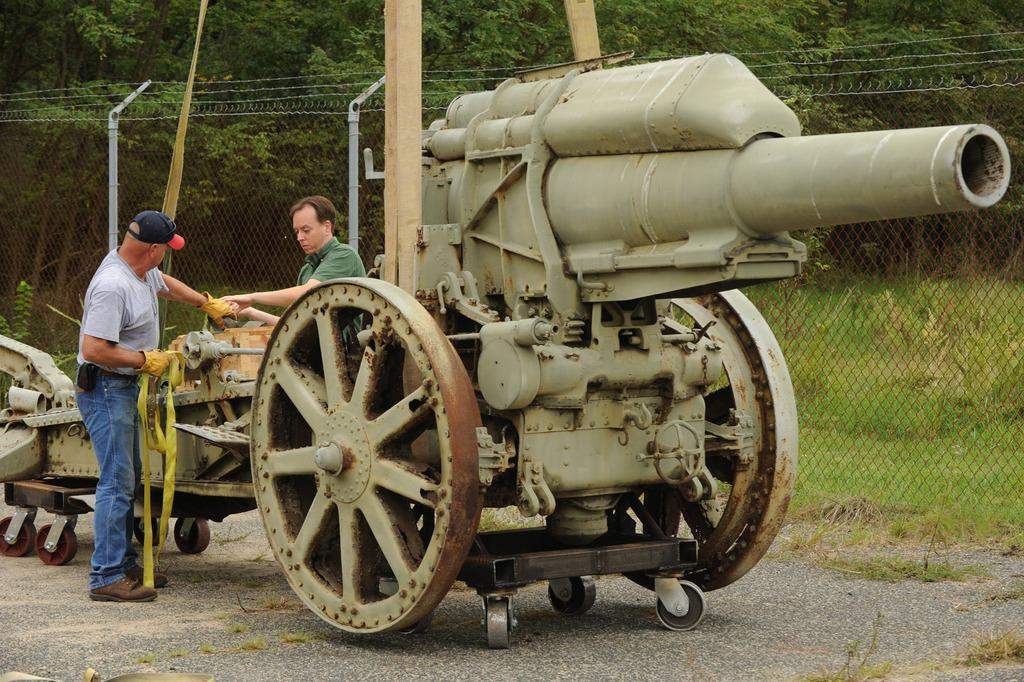What is the main object in the foreground of the image? There is a cannon on the road in the foreground of the image. Who is present near the cannon? Two people are standing near the cannon. What are the people holding? The people are holding a belt-like object. What can be seen in the background of the image? There is fencing and trees in the background of the image. How does the cannon attract the attention of the judge in the image? There is no judge present in the image, and the cannon does not attract anyone's attention. 